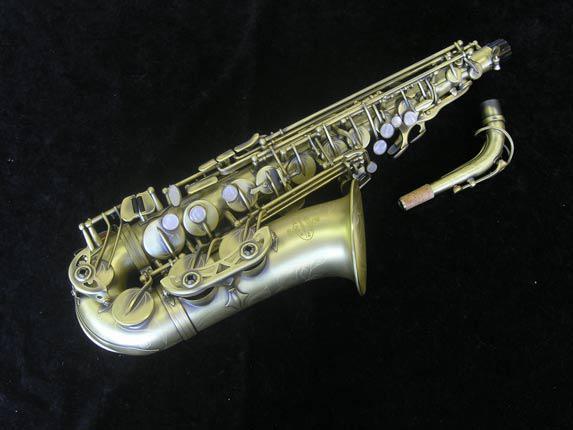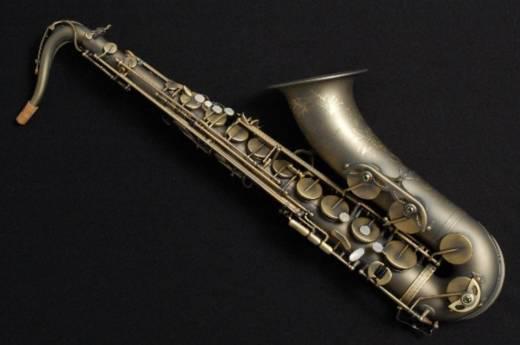The first image is the image on the left, the second image is the image on the right. Considering the images on both sides, is "The instruments in the left and right images share the same directional position and angle." valid? Answer yes or no. No. 